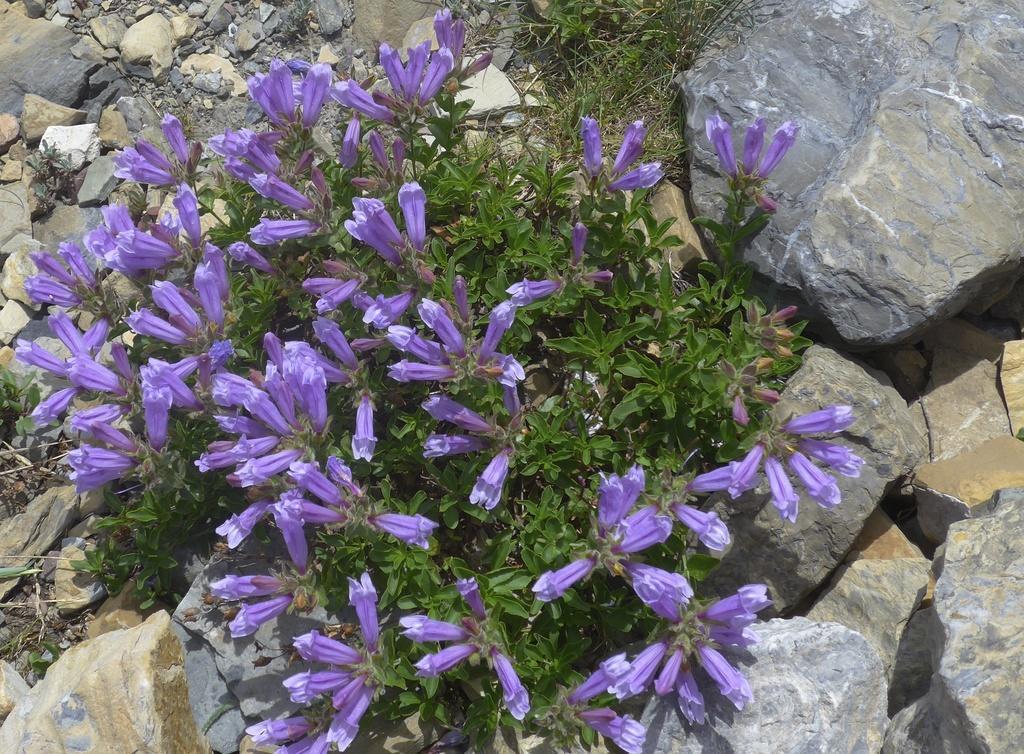How would you summarize this image in a sentence or two? In this image we can see some plants with flowers and we can see the flowers in a purple color. In the background, we can see some rocks. 